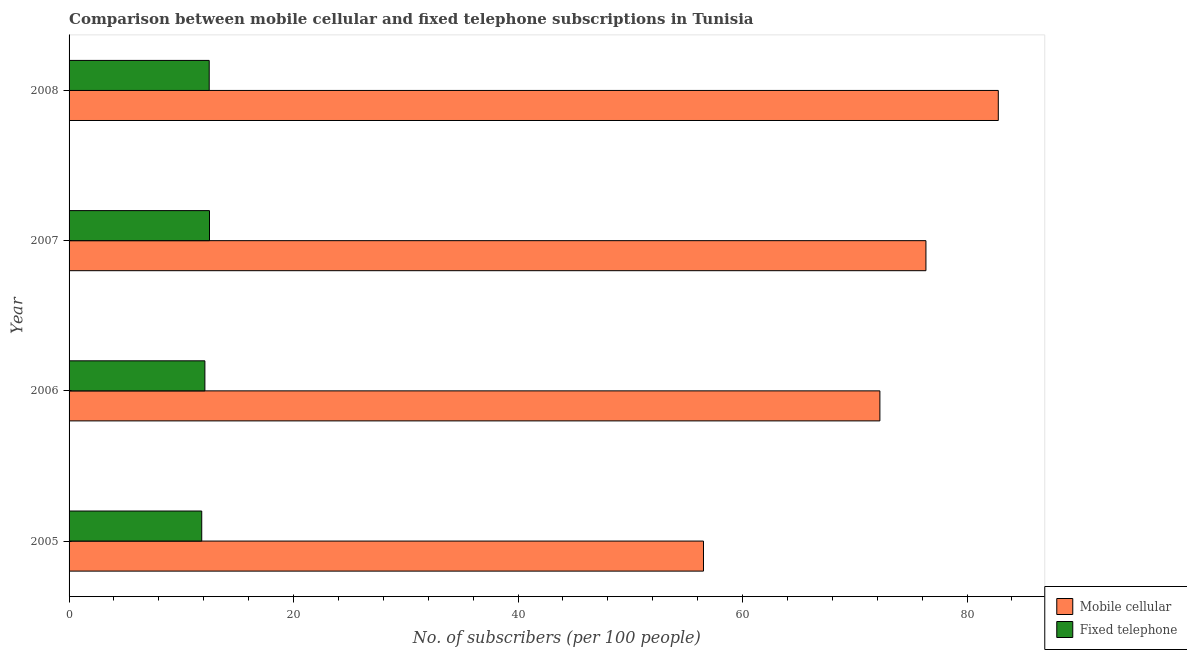How many different coloured bars are there?
Give a very brief answer. 2. Are the number of bars per tick equal to the number of legend labels?
Ensure brevity in your answer.  Yes. How many bars are there on the 2nd tick from the bottom?
Give a very brief answer. 2. In how many cases, is the number of bars for a given year not equal to the number of legend labels?
Provide a short and direct response. 0. What is the number of fixed telephone subscribers in 2008?
Provide a short and direct response. 12.48. Across all years, what is the maximum number of fixed telephone subscribers?
Make the answer very short. 12.51. Across all years, what is the minimum number of fixed telephone subscribers?
Your answer should be compact. 11.82. In which year was the number of mobile cellular subscribers maximum?
Provide a succinct answer. 2008. What is the total number of mobile cellular subscribers in the graph?
Give a very brief answer. 287.87. What is the difference between the number of fixed telephone subscribers in 2006 and that in 2007?
Make the answer very short. -0.41. What is the difference between the number of mobile cellular subscribers in 2007 and the number of fixed telephone subscribers in 2005?
Your response must be concise. 64.52. What is the average number of mobile cellular subscribers per year?
Provide a succinct answer. 71.97. In the year 2005, what is the difference between the number of fixed telephone subscribers and number of mobile cellular subscribers?
Offer a very short reply. -44.7. What is the ratio of the number of mobile cellular subscribers in 2005 to that in 2007?
Keep it short and to the point. 0.74. Is the number of fixed telephone subscribers in 2006 less than that in 2008?
Offer a very short reply. Yes. Is the difference between the number of mobile cellular subscribers in 2006 and 2008 greater than the difference between the number of fixed telephone subscribers in 2006 and 2008?
Keep it short and to the point. No. What is the difference between the highest and the second highest number of fixed telephone subscribers?
Provide a succinct answer. 0.03. What is the difference between the highest and the lowest number of mobile cellular subscribers?
Make the answer very short. 26.26. What does the 2nd bar from the top in 2006 represents?
Keep it short and to the point. Mobile cellular. What does the 1st bar from the bottom in 2005 represents?
Your response must be concise. Mobile cellular. Are all the bars in the graph horizontal?
Provide a short and direct response. Yes. How many years are there in the graph?
Your response must be concise. 4. What is the difference between two consecutive major ticks on the X-axis?
Provide a succinct answer. 20. Does the graph contain grids?
Your answer should be very brief. No. How many legend labels are there?
Ensure brevity in your answer.  2. How are the legend labels stacked?
Provide a succinct answer. Vertical. What is the title of the graph?
Your answer should be compact. Comparison between mobile cellular and fixed telephone subscriptions in Tunisia. Does "Registered firms" appear as one of the legend labels in the graph?
Keep it short and to the point. No. What is the label or title of the X-axis?
Offer a terse response. No. of subscribers (per 100 people). What is the No. of subscribers (per 100 people) of Mobile cellular in 2005?
Give a very brief answer. 56.52. What is the No. of subscribers (per 100 people) of Fixed telephone in 2005?
Offer a very short reply. 11.82. What is the No. of subscribers (per 100 people) in Mobile cellular in 2006?
Make the answer very short. 72.23. What is the No. of subscribers (per 100 people) in Fixed telephone in 2006?
Provide a short and direct response. 12.1. What is the No. of subscribers (per 100 people) in Mobile cellular in 2007?
Offer a terse response. 76.34. What is the No. of subscribers (per 100 people) in Fixed telephone in 2007?
Make the answer very short. 12.51. What is the No. of subscribers (per 100 people) in Mobile cellular in 2008?
Your answer should be very brief. 82.78. What is the No. of subscribers (per 100 people) in Fixed telephone in 2008?
Make the answer very short. 12.48. Across all years, what is the maximum No. of subscribers (per 100 people) of Mobile cellular?
Provide a succinct answer. 82.78. Across all years, what is the maximum No. of subscribers (per 100 people) of Fixed telephone?
Make the answer very short. 12.51. Across all years, what is the minimum No. of subscribers (per 100 people) in Mobile cellular?
Your response must be concise. 56.52. Across all years, what is the minimum No. of subscribers (per 100 people) of Fixed telephone?
Keep it short and to the point. 11.82. What is the total No. of subscribers (per 100 people) of Mobile cellular in the graph?
Your response must be concise. 287.87. What is the total No. of subscribers (per 100 people) in Fixed telephone in the graph?
Keep it short and to the point. 48.91. What is the difference between the No. of subscribers (per 100 people) of Mobile cellular in 2005 and that in 2006?
Provide a short and direct response. -15.72. What is the difference between the No. of subscribers (per 100 people) of Fixed telephone in 2005 and that in 2006?
Provide a succinct answer. -0.28. What is the difference between the No. of subscribers (per 100 people) in Mobile cellular in 2005 and that in 2007?
Provide a short and direct response. -19.82. What is the difference between the No. of subscribers (per 100 people) of Fixed telephone in 2005 and that in 2007?
Offer a terse response. -0.69. What is the difference between the No. of subscribers (per 100 people) of Mobile cellular in 2005 and that in 2008?
Your answer should be compact. -26.26. What is the difference between the No. of subscribers (per 100 people) of Fixed telephone in 2005 and that in 2008?
Your answer should be very brief. -0.67. What is the difference between the No. of subscribers (per 100 people) in Mobile cellular in 2006 and that in 2007?
Ensure brevity in your answer.  -4.1. What is the difference between the No. of subscribers (per 100 people) in Fixed telephone in 2006 and that in 2007?
Make the answer very short. -0.41. What is the difference between the No. of subscribers (per 100 people) in Mobile cellular in 2006 and that in 2008?
Keep it short and to the point. -10.55. What is the difference between the No. of subscribers (per 100 people) in Fixed telephone in 2006 and that in 2008?
Provide a succinct answer. -0.39. What is the difference between the No. of subscribers (per 100 people) of Mobile cellular in 2007 and that in 2008?
Give a very brief answer. -6.45. What is the difference between the No. of subscribers (per 100 people) of Fixed telephone in 2007 and that in 2008?
Provide a succinct answer. 0.03. What is the difference between the No. of subscribers (per 100 people) in Mobile cellular in 2005 and the No. of subscribers (per 100 people) in Fixed telephone in 2006?
Provide a succinct answer. 44.42. What is the difference between the No. of subscribers (per 100 people) in Mobile cellular in 2005 and the No. of subscribers (per 100 people) in Fixed telephone in 2007?
Provide a short and direct response. 44.01. What is the difference between the No. of subscribers (per 100 people) in Mobile cellular in 2005 and the No. of subscribers (per 100 people) in Fixed telephone in 2008?
Make the answer very short. 44.03. What is the difference between the No. of subscribers (per 100 people) in Mobile cellular in 2006 and the No. of subscribers (per 100 people) in Fixed telephone in 2007?
Provide a short and direct response. 59.72. What is the difference between the No. of subscribers (per 100 people) of Mobile cellular in 2006 and the No. of subscribers (per 100 people) of Fixed telephone in 2008?
Keep it short and to the point. 59.75. What is the difference between the No. of subscribers (per 100 people) of Mobile cellular in 2007 and the No. of subscribers (per 100 people) of Fixed telephone in 2008?
Provide a short and direct response. 63.85. What is the average No. of subscribers (per 100 people) in Mobile cellular per year?
Give a very brief answer. 71.97. What is the average No. of subscribers (per 100 people) of Fixed telephone per year?
Your response must be concise. 12.23. In the year 2005, what is the difference between the No. of subscribers (per 100 people) of Mobile cellular and No. of subscribers (per 100 people) of Fixed telephone?
Provide a short and direct response. 44.7. In the year 2006, what is the difference between the No. of subscribers (per 100 people) of Mobile cellular and No. of subscribers (per 100 people) of Fixed telephone?
Your answer should be very brief. 60.13. In the year 2007, what is the difference between the No. of subscribers (per 100 people) in Mobile cellular and No. of subscribers (per 100 people) in Fixed telephone?
Ensure brevity in your answer.  63.82. In the year 2008, what is the difference between the No. of subscribers (per 100 people) of Mobile cellular and No. of subscribers (per 100 people) of Fixed telephone?
Provide a succinct answer. 70.3. What is the ratio of the No. of subscribers (per 100 people) in Mobile cellular in 2005 to that in 2006?
Offer a terse response. 0.78. What is the ratio of the No. of subscribers (per 100 people) of Fixed telephone in 2005 to that in 2006?
Offer a very short reply. 0.98. What is the ratio of the No. of subscribers (per 100 people) in Mobile cellular in 2005 to that in 2007?
Your answer should be very brief. 0.74. What is the ratio of the No. of subscribers (per 100 people) in Fixed telephone in 2005 to that in 2007?
Your answer should be compact. 0.94. What is the ratio of the No. of subscribers (per 100 people) of Mobile cellular in 2005 to that in 2008?
Your response must be concise. 0.68. What is the ratio of the No. of subscribers (per 100 people) in Fixed telephone in 2005 to that in 2008?
Your answer should be very brief. 0.95. What is the ratio of the No. of subscribers (per 100 people) in Mobile cellular in 2006 to that in 2007?
Offer a terse response. 0.95. What is the ratio of the No. of subscribers (per 100 people) of Fixed telephone in 2006 to that in 2007?
Give a very brief answer. 0.97. What is the ratio of the No. of subscribers (per 100 people) in Mobile cellular in 2006 to that in 2008?
Offer a very short reply. 0.87. What is the ratio of the No. of subscribers (per 100 people) in Fixed telephone in 2006 to that in 2008?
Your answer should be very brief. 0.97. What is the ratio of the No. of subscribers (per 100 people) in Mobile cellular in 2007 to that in 2008?
Keep it short and to the point. 0.92. What is the difference between the highest and the second highest No. of subscribers (per 100 people) in Mobile cellular?
Offer a very short reply. 6.45. What is the difference between the highest and the second highest No. of subscribers (per 100 people) in Fixed telephone?
Give a very brief answer. 0.03. What is the difference between the highest and the lowest No. of subscribers (per 100 people) of Mobile cellular?
Your response must be concise. 26.26. What is the difference between the highest and the lowest No. of subscribers (per 100 people) in Fixed telephone?
Your answer should be very brief. 0.69. 